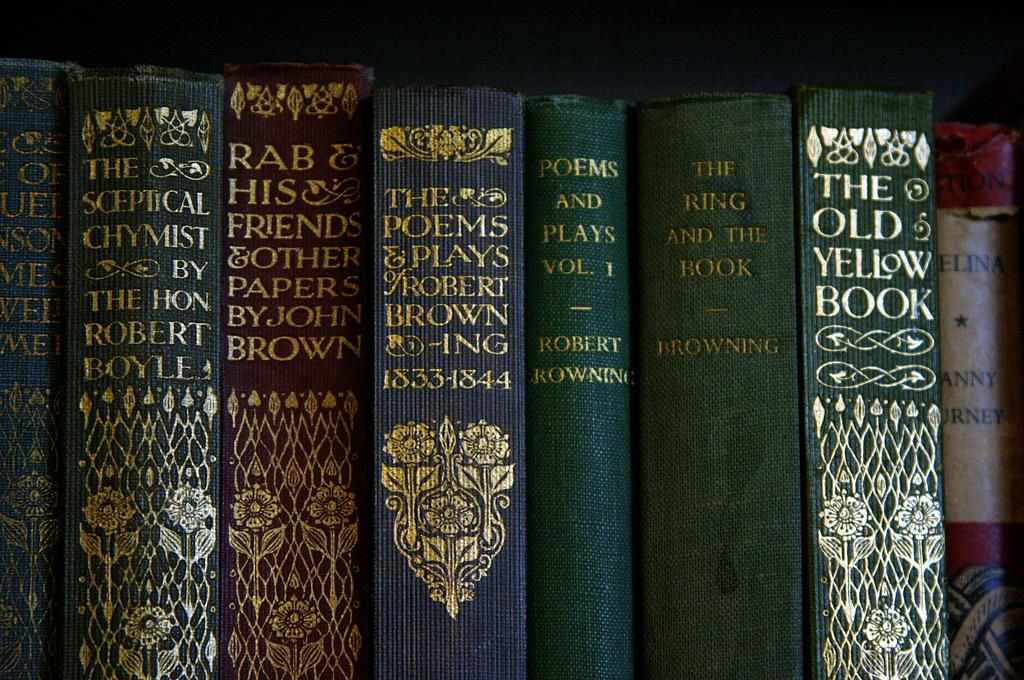Provide a one-sentence caption for the provided image. Come by and read The Poems &Play by Robert Brown. 